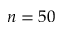<formula> <loc_0><loc_0><loc_500><loc_500>n = 5 0</formula> 